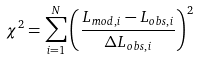<formula> <loc_0><loc_0><loc_500><loc_500>\chi ^ { 2 } = \sum _ { i = 1 } ^ { N } \left ( \frac { L _ { m o d , i } - L _ { o b s , i } } { \Delta L _ { o b s , i } } \right ) ^ { 2 }</formula> 